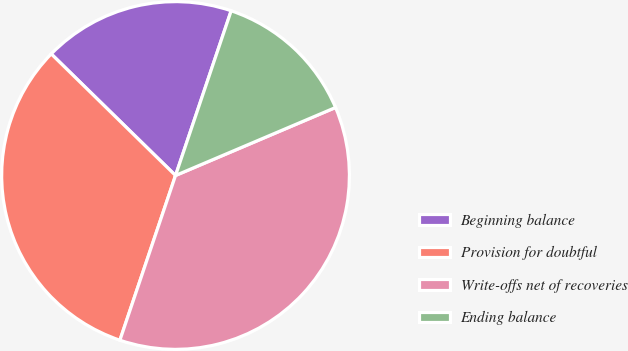Convert chart. <chart><loc_0><loc_0><loc_500><loc_500><pie_chart><fcel>Beginning balance<fcel>Provision for doubtful<fcel>Write-offs net of recoveries<fcel>Ending balance<nl><fcel>17.86%<fcel>32.14%<fcel>36.58%<fcel>13.42%<nl></chart> 